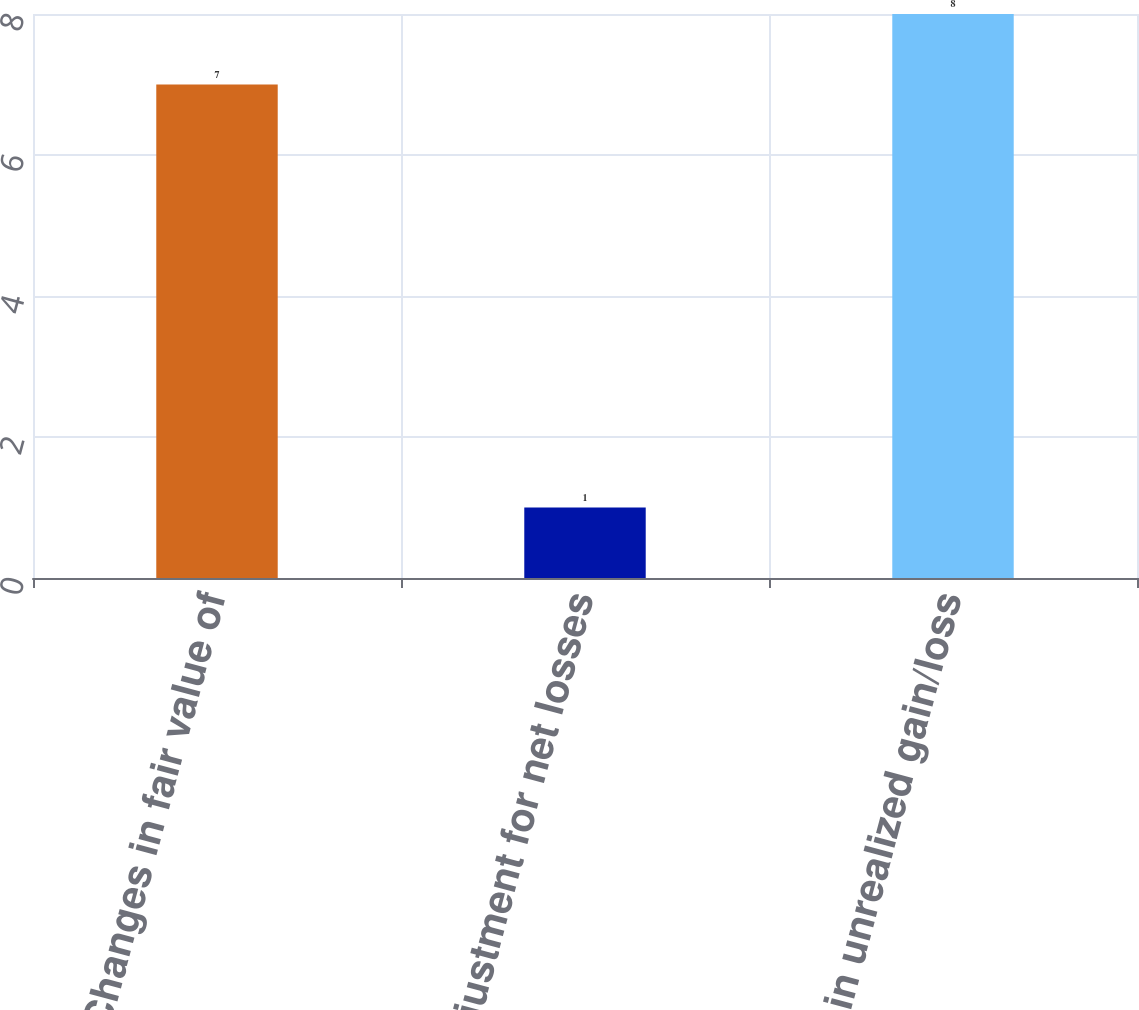Convert chart to OTSL. <chart><loc_0><loc_0><loc_500><loc_500><bar_chart><fcel>Changes in fair value of<fcel>Adjustment for net losses<fcel>Change in unrealized gain/loss<nl><fcel>7<fcel>1<fcel>8<nl></chart> 